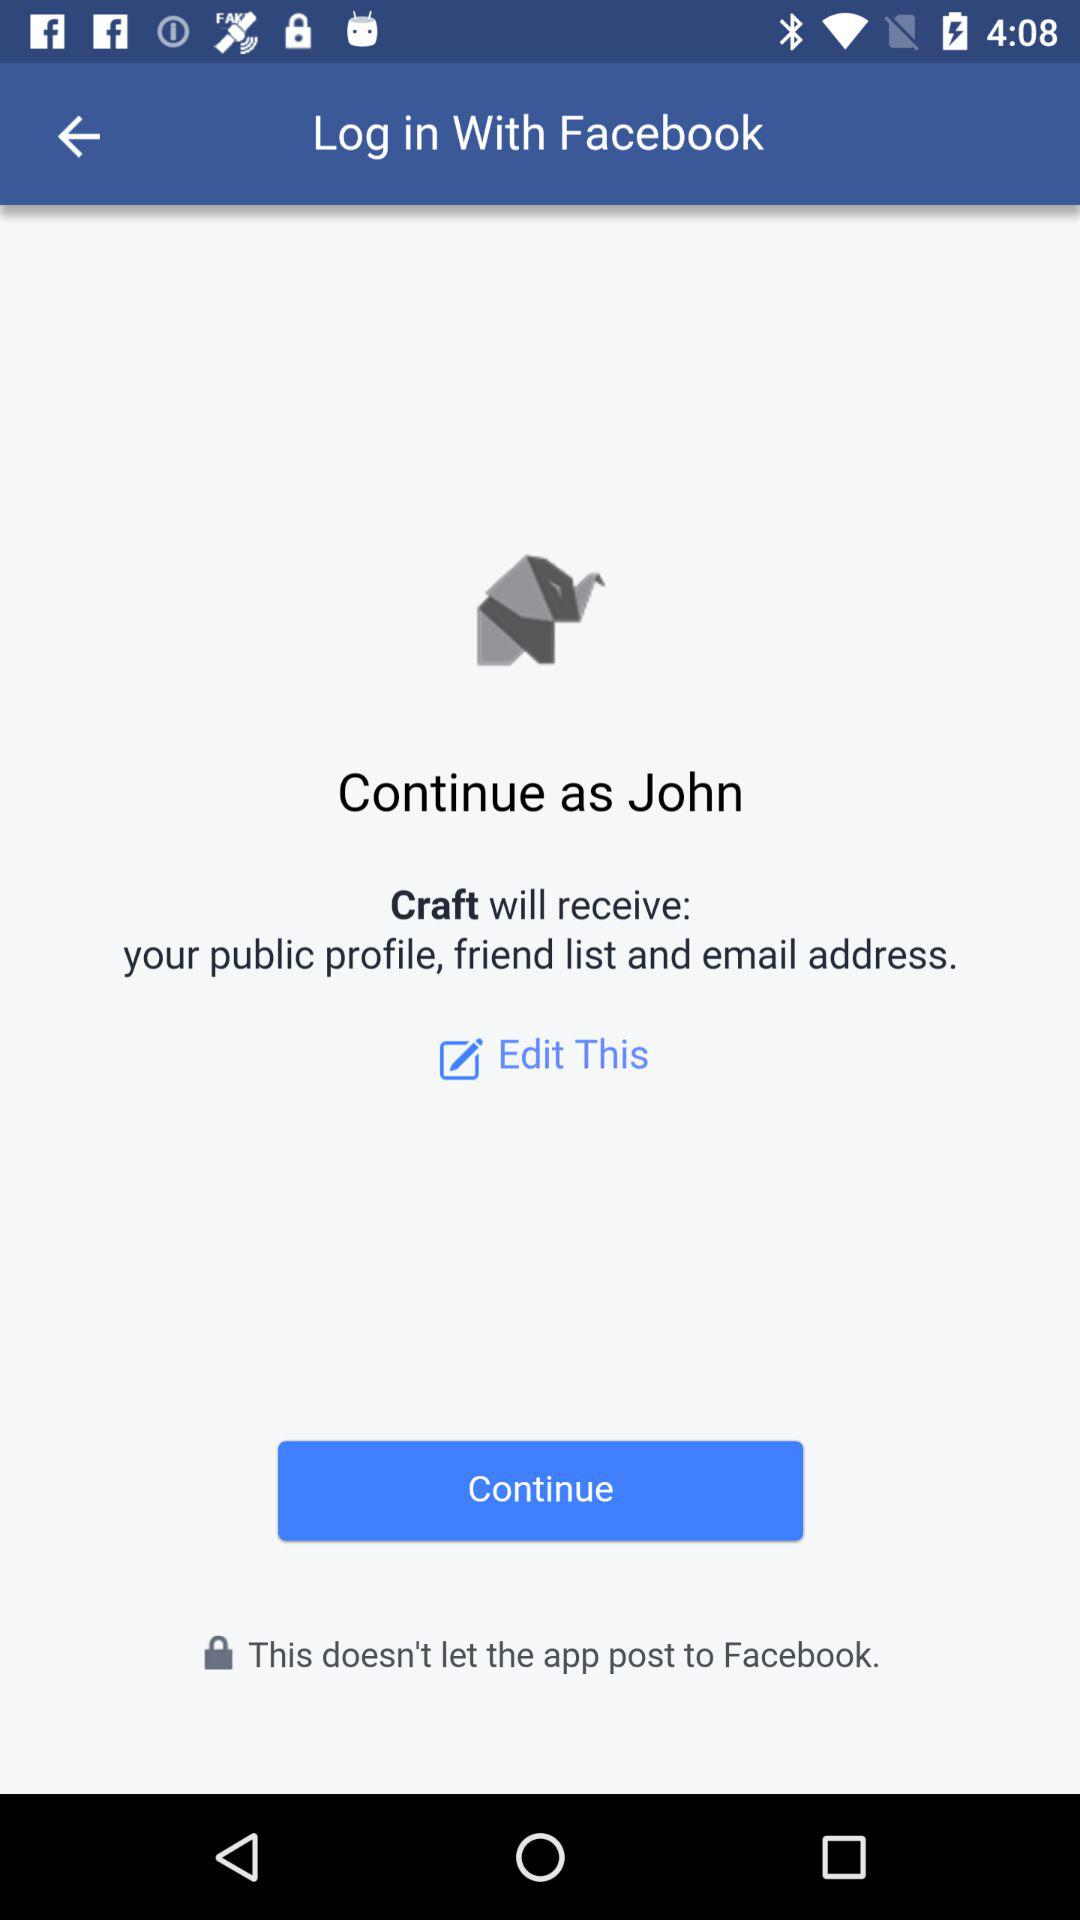What application is asking for permission? The application that is asking for permission is "Craft". 